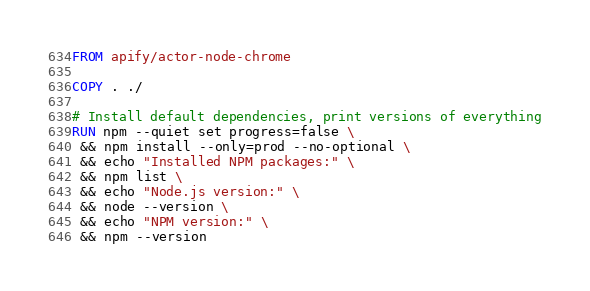<code> <loc_0><loc_0><loc_500><loc_500><_Dockerfile_>FROM apify/actor-node-chrome

COPY . ./

# Install default dependencies, print versions of everything
RUN npm --quiet set progress=false \
 && npm install --only=prod --no-optional \
 && echo "Installed NPM packages:" \
 && npm list \
 && echo "Node.js version:" \
 && node --version \
 && echo "NPM version:" \
 && npm --version
</code> 